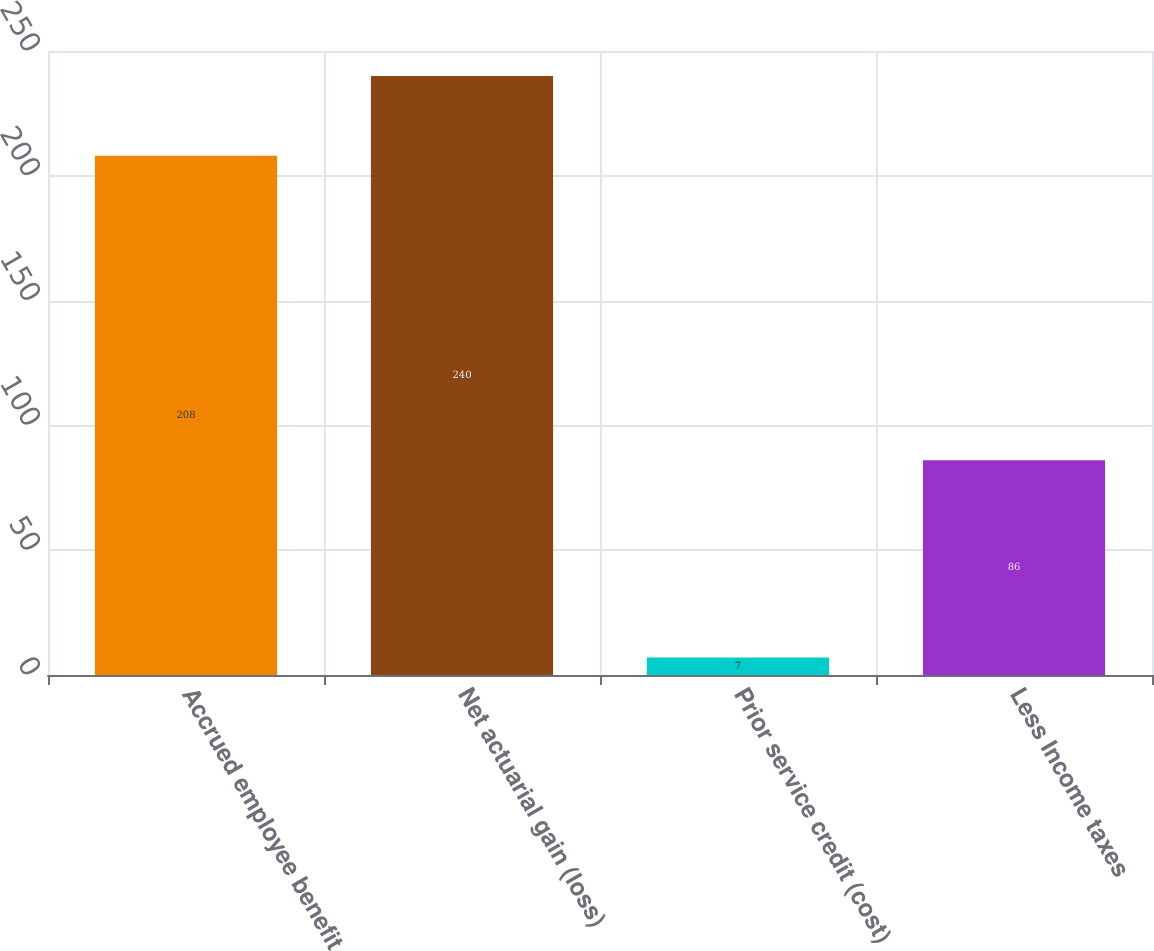Convert chart. <chart><loc_0><loc_0><loc_500><loc_500><bar_chart><fcel>Accrued employee benefit<fcel>Net actuarial gain (loss)<fcel>Prior service credit (cost)<fcel>Less Income taxes<nl><fcel>208<fcel>240<fcel>7<fcel>86<nl></chart> 